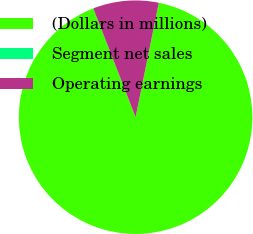<chart> <loc_0><loc_0><loc_500><loc_500><pie_chart><fcel>(Dollars in millions)<fcel>Segment net sales<fcel>Operating earnings<nl><fcel>90.91%<fcel>0.0%<fcel>9.09%<nl></chart> 